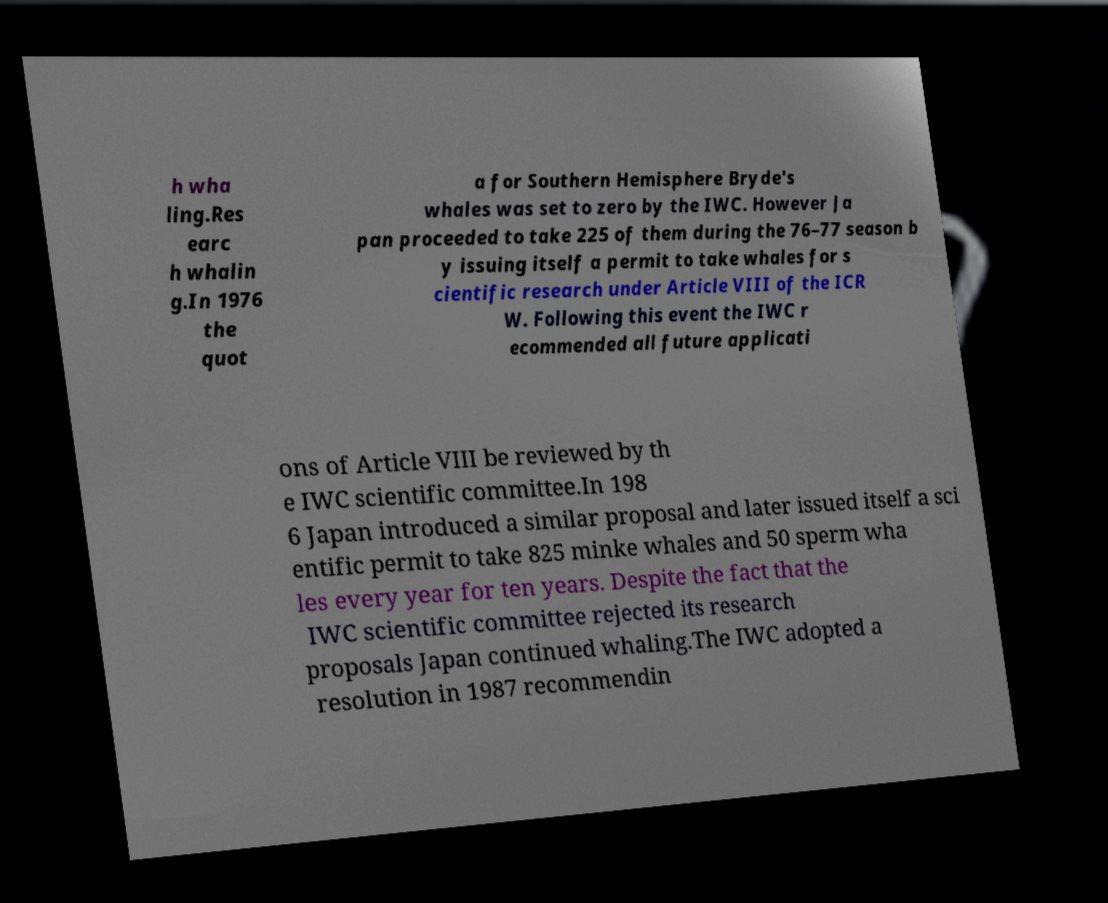Please identify and transcribe the text found in this image. h wha ling.Res earc h whalin g.In 1976 the quot a for Southern Hemisphere Bryde's whales was set to zero by the IWC. However Ja pan proceeded to take 225 of them during the 76–77 season b y issuing itself a permit to take whales for s cientific research under Article VIII of the ICR W. Following this event the IWC r ecommended all future applicati ons of Article VIII be reviewed by th e IWC scientific committee.In 198 6 Japan introduced a similar proposal and later issued itself a sci entific permit to take 825 minke whales and 50 sperm wha les every year for ten years. Despite the fact that the IWC scientific committee rejected its research proposals Japan continued whaling.The IWC adopted a resolution in 1987 recommendin 